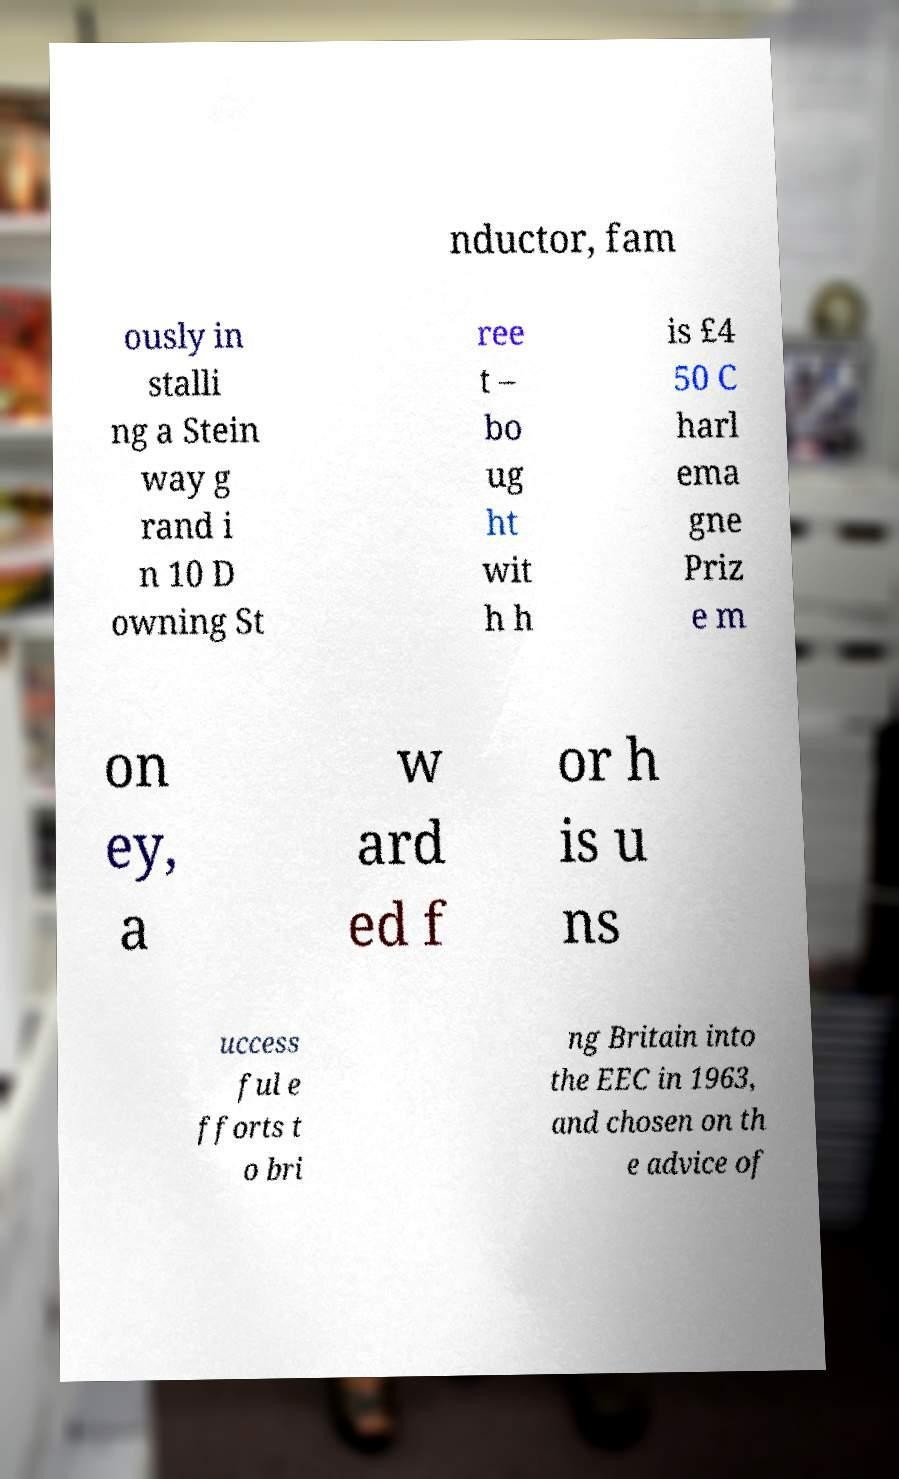I need the written content from this picture converted into text. Can you do that? nductor, fam ously in stalli ng a Stein way g rand i n 10 D owning St ree t – bo ug ht wit h h is £4 50 C harl ema gne Priz e m on ey, a w ard ed f or h is u ns uccess ful e fforts t o bri ng Britain into the EEC in 1963, and chosen on th e advice of 